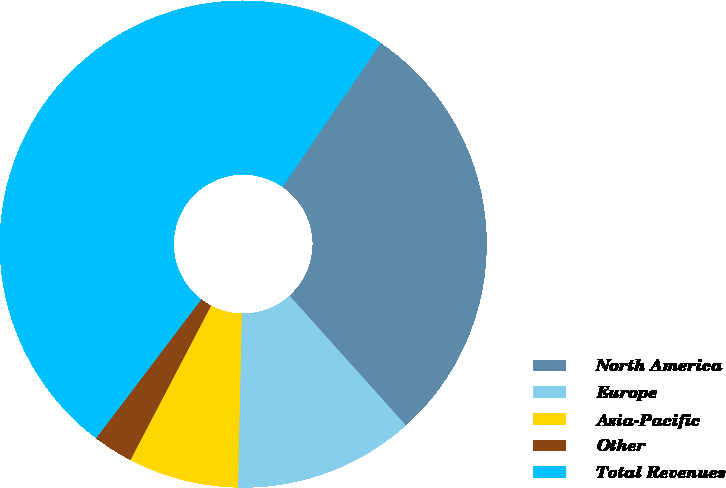Convert chart to OTSL. <chart><loc_0><loc_0><loc_500><loc_500><pie_chart><fcel>North America<fcel>Europe<fcel>Asia-Pacific<fcel>Other<fcel>Total Revenues<nl><fcel>28.81%<fcel>11.98%<fcel>7.32%<fcel>2.66%<fcel>49.23%<nl></chart> 